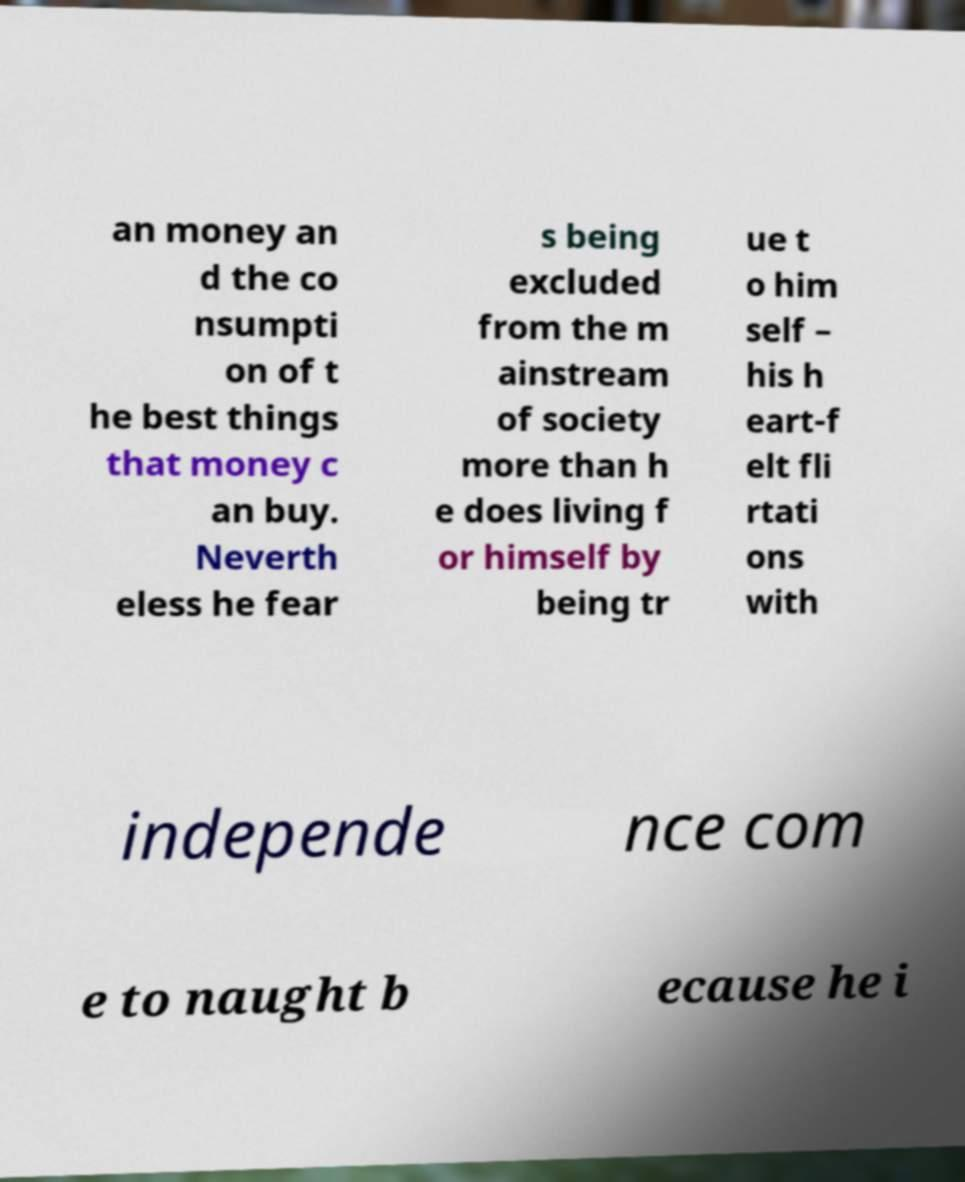Could you extract and type out the text from this image? an money an d the co nsumpti on of t he best things that money c an buy. Neverth eless he fear s being excluded from the m ainstream of society more than h e does living f or himself by being tr ue t o him self – his h eart-f elt fli rtati ons with independe nce com e to naught b ecause he i 